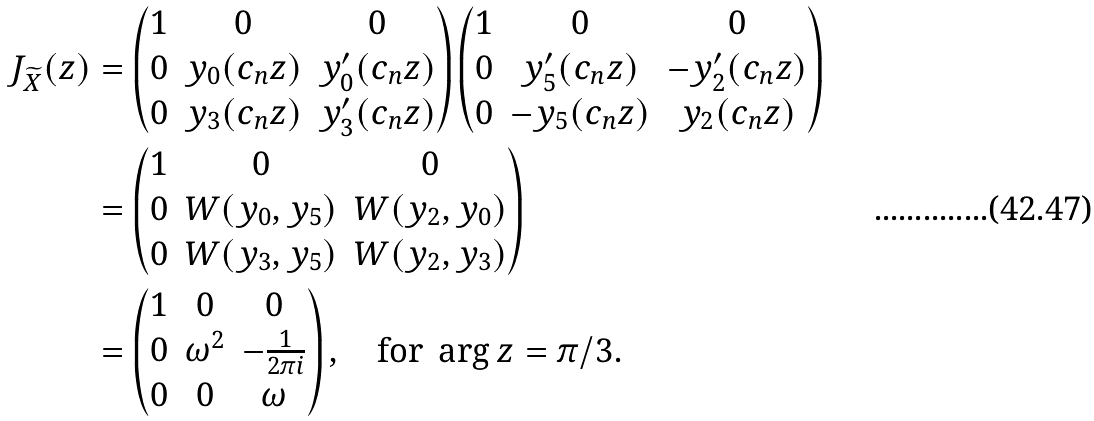<formula> <loc_0><loc_0><loc_500><loc_500>J _ { \widetilde { X } } ( z ) & = \begin{pmatrix} 1 & 0 & 0 \\ 0 & y _ { 0 } ( c _ { n } z ) & y _ { 0 } ^ { \prime } ( c _ { n } z ) \\ 0 & y _ { 3 } ( c _ { n } z ) & y _ { 3 } ^ { \prime } ( c _ { n } z ) \end{pmatrix} \begin{pmatrix} 1 & 0 & 0 \\ 0 & y _ { 5 } ^ { \prime } ( c _ { n } z ) & - y _ { 2 } ^ { \prime } ( c _ { n } z ) \\ 0 & - y _ { 5 } ( c _ { n } z ) & y _ { 2 } ( c _ { n } z ) \end{pmatrix} \\ & = \begin{pmatrix} 1 & 0 & 0 \\ 0 & W ( y _ { 0 } , y _ { 5 } ) & W ( y _ { 2 } , y _ { 0 } ) \\ 0 & W ( y _ { 3 } , y _ { 5 } ) & W ( y _ { 2 } , y _ { 3 } ) \end{pmatrix} \\ & = \begin{pmatrix} 1 & 0 & 0 \\ 0 & \omega ^ { 2 } & - \frac { 1 } { 2 \pi i } \\ 0 & 0 & \omega \end{pmatrix} , \quad \text {for } \arg z = \pi / 3 .</formula> 